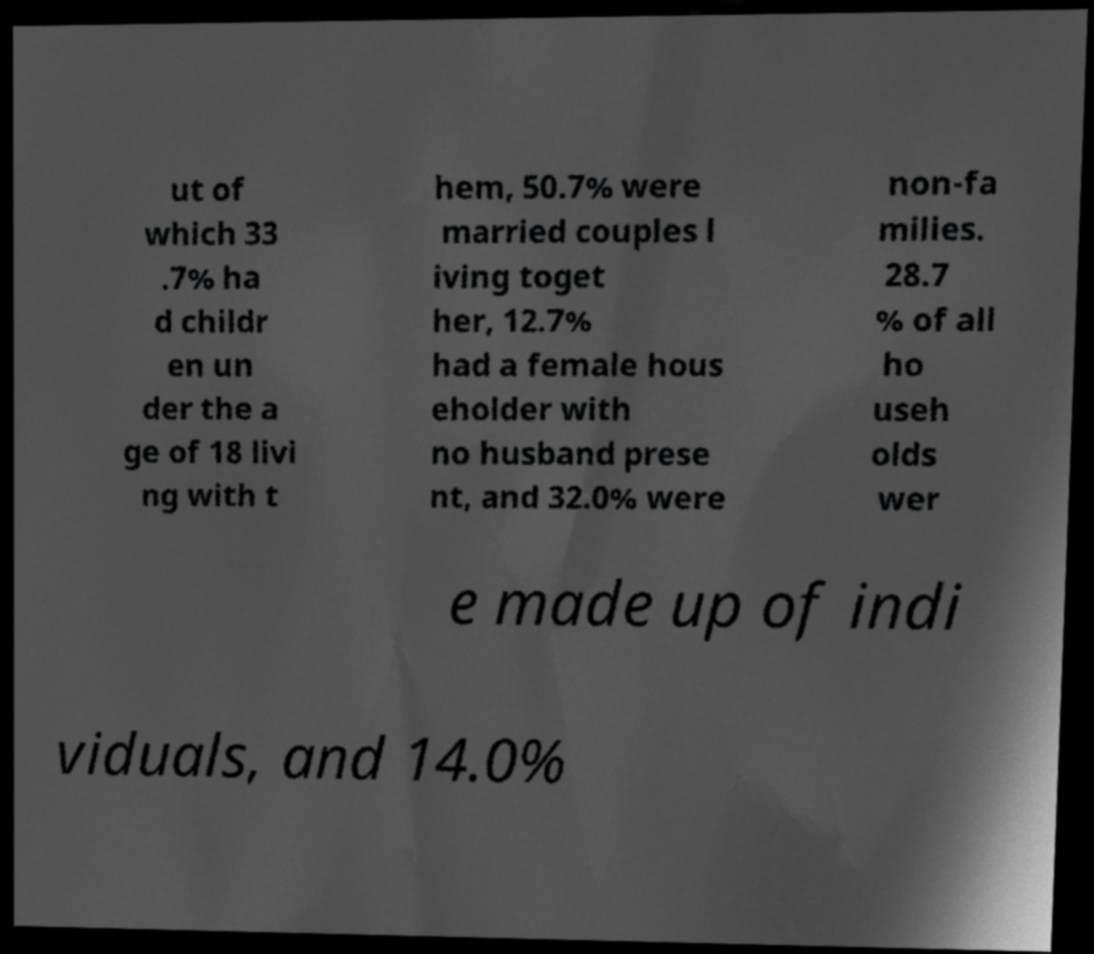Can you accurately transcribe the text from the provided image for me? ut of which 33 .7% ha d childr en un der the a ge of 18 livi ng with t hem, 50.7% were married couples l iving toget her, 12.7% had a female hous eholder with no husband prese nt, and 32.0% were non-fa milies. 28.7 % of all ho useh olds wer e made up of indi viduals, and 14.0% 